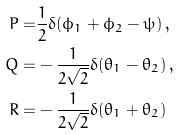<formula> <loc_0><loc_0><loc_500><loc_500>P = & \frac { 1 } { 2 } \delta ( \phi _ { 1 } + \phi _ { 2 } - \psi ) \, , \\ Q = & - \frac { 1 } { 2 \sqrt { 2 } } \delta ( \theta _ { 1 } - \theta _ { 2 } ) \, , \\ R = & - \frac { 1 } { 2 \sqrt { 2 } } \delta ( \theta _ { 1 } + \theta _ { 2 } ) \,</formula> 